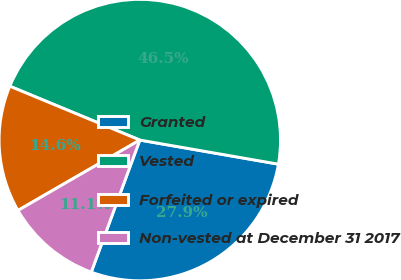Convert chart. <chart><loc_0><loc_0><loc_500><loc_500><pie_chart><fcel>Granted<fcel>Vested<fcel>Forfeited or expired<fcel>Non-vested at December 31 2017<nl><fcel>27.87%<fcel>46.49%<fcel>14.59%<fcel>11.05%<nl></chart> 